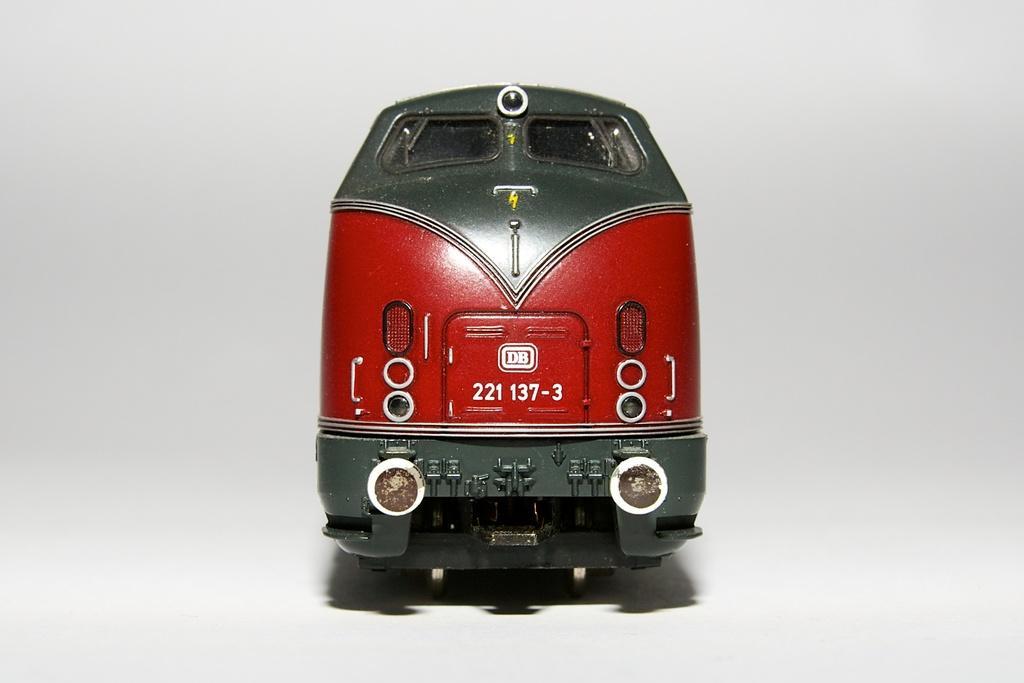Can you describe this image briefly? In this image I can see a train which is red, green and white in color. I can see the white colored background. 